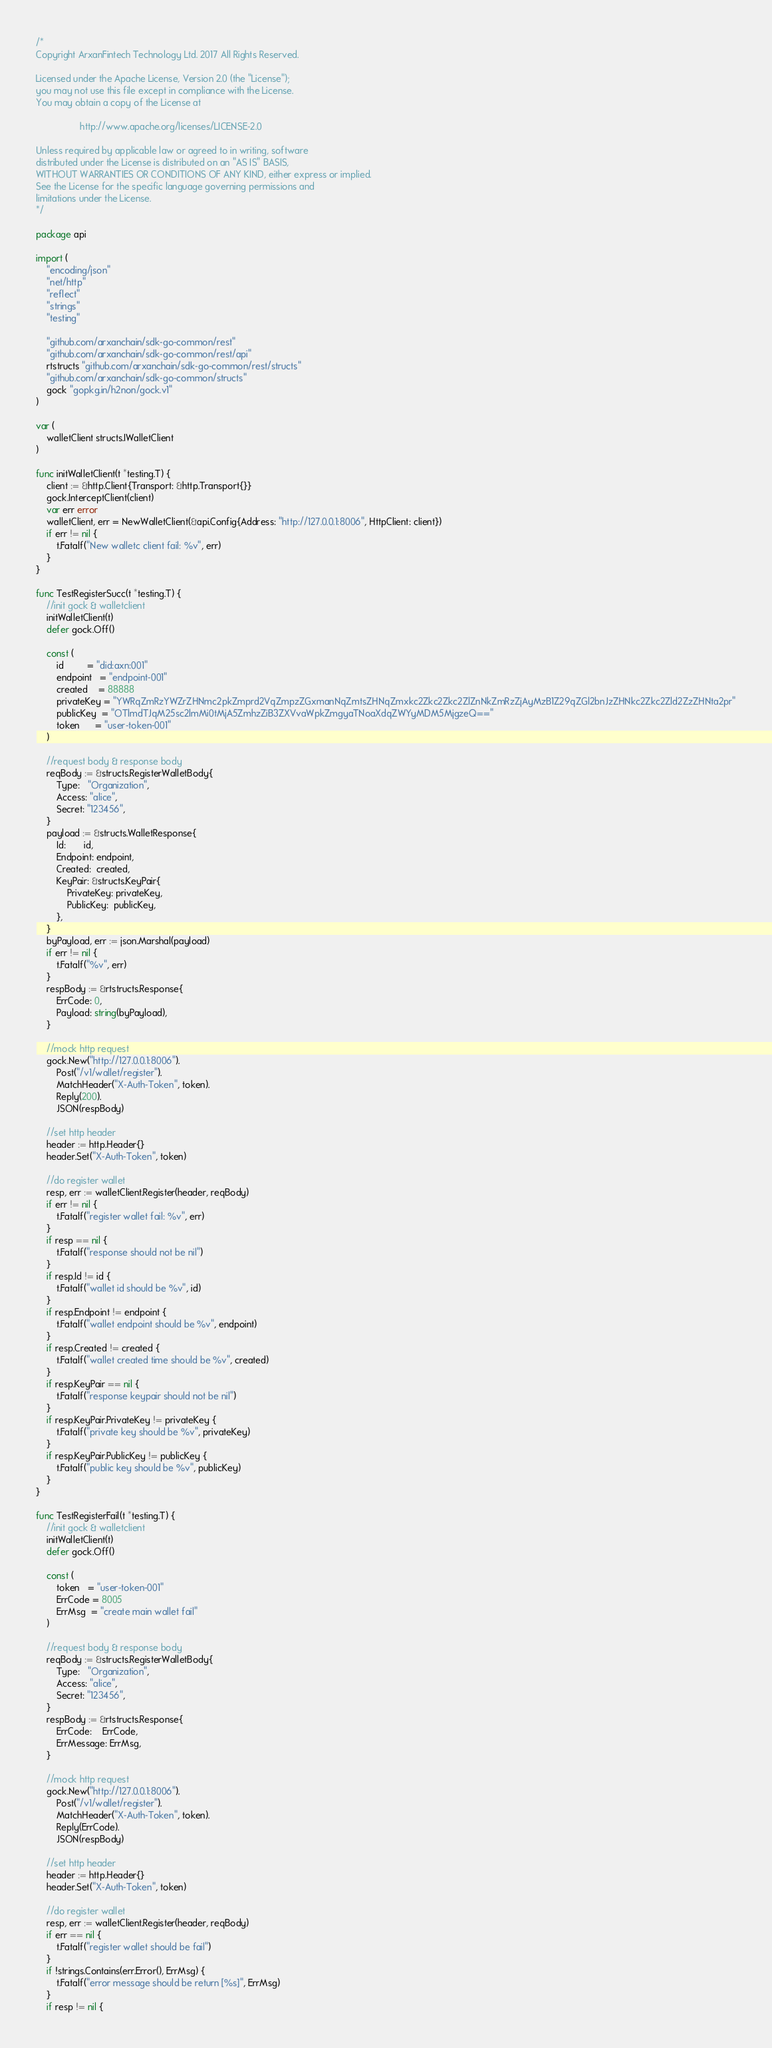Convert code to text. <code><loc_0><loc_0><loc_500><loc_500><_Go_>/*
Copyright ArxanFintech Technology Ltd. 2017 All Rights Reserved.

Licensed under the Apache License, Version 2.0 (the "License");
you may not use this file except in compliance with the License.
You may obtain a copy of the License at

                 http://www.apache.org/licenses/LICENSE-2.0

Unless required by applicable law or agreed to in writing, software
distributed under the License is distributed on an "AS IS" BASIS,
WITHOUT WARRANTIES OR CONDITIONS OF ANY KIND, either express or implied.
See the License for the specific language governing permissions and
limitations under the License.
*/

package api

import (
	"encoding/json"
	"net/http"
	"reflect"
	"strings"
	"testing"

	"github.com/arxanchain/sdk-go-common/rest"
	"github.com/arxanchain/sdk-go-common/rest/api"
	rtstructs "github.com/arxanchain/sdk-go-common/rest/structs"
	"github.com/arxanchain/sdk-go-common/structs"
	gock "gopkg.in/h2non/gock.v1"
)

var (
	walletClient structs.IWalletClient
)

func initWalletClient(t *testing.T) {
	client := &http.Client{Transport: &http.Transport{}}
	gock.InterceptClient(client)
	var err error
	walletClient, err = NewWalletClient(&api.Config{Address: "http://127.0.0.1:8006", HttpClient: client})
	if err != nil {
		t.Fatalf("New walletc client fail: %v", err)
	}
}

func TestRegisterSucc(t *testing.T) {
	//init gock & walletclient
	initWalletClient(t)
	defer gock.Off()

	const (
		id         = "did:axn:001"
		endpoint   = "endpoint-001"
		created    = 88888
		privateKey = "YWRqZmRzYWZrZHNmc2pkZmprd2VqZmpzZGxmanNqZmtsZHNqZmxkc2Zkc2Zkc2ZlZnNkZmRzZjAyMzB1Z29qZGl2bnJzZHNkc2Zkc2Zld2ZzZHNta2pr"
		publicKey  = "OTlmdTJqM25sc2lmMi0tMjA5ZmhzZiB3ZXVvaWpkZmgyaTNoaXdqZWYyMDM5MjgzeQ=="
		token      = "user-token-001"
	)

	//request body & response body
	reqBody := &structs.RegisterWalletBody{
		Type:   "Organization",
		Access: "alice",
		Secret: "123456",
	}
	payload := &structs.WalletResponse{
		Id:       id,
		Endpoint: endpoint,
		Created:  created,
		KeyPair: &structs.KeyPair{
			PrivateKey: privateKey,
			PublicKey:  publicKey,
		},
	}
	byPayload, err := json.Marshal(payload)
	if err != nil {
		t.Fatalf("%v", err)
	}
	respBody := &rtstructs.Response{
		ErrCode: 0,
		Payload: string(byPayload),
	}

	//mock http request
	gock.New("http://127.0.0.1:8006").
		Post("/v1/wallet/register").
		MatchHeader("X-Auth-Token", token).
		Reply(200).
		JSON(respBody)

	//set http header
	header := http.Header{}
	header.Set("X-Auth-Token", token)

	//do register wallet
	resp, err := walletClient.Register(header, reqBody)
	if err != nil {
		t.Fatalf("register wallet fail: %v", err)
	}
	if resp == nil {
		t.Fatalf("response should not be nil")
	}
	if resp.Id != id {
		t.Fatalf("wallet id should be %v", id)
	}
	if resp.Endpoint != endpoint {
		t.Fatalf("wallet endpoint should be %v", endpoint)
	}
	if resp.Created != created {
		t.Fatalf("wallet created time should be %v", created)
	}
	if resp.KeyPair == nil {
		t.Fatalf("response keypair should not be nil")
	}
	if resp.KeyPair.PrivateKey != privateKey {
		t.Fatalf("private key should be %v", privateKey)
	}
	if resp.KeyPair.PublicKey != publicKey {
		t.Fatalf("public key should be %v", publicKey)
	}
}

func TestRegisterFail(t *testing.T) {
	//init gock & walletclient
	initWalletClient(t)
	defer gock.Off()

	const (
		token   = "user-token-001"
		ErrCode = 8005
		ErrMsg  = "create main wallet fail"
	)

	//request body & response body
	reqBody := &structs.RegisterWalletBody{
		Type:   "Organization",
		Access: "alice",
		Secret: "123456",
	}
	respBody := &rtstructs.Response{
		ErrCode:    ErrCode,
		ErrMessage: ErrMsg,
	}

	//mock http request
	gock.New("http://127.0.0.1:8006").
		Post("/v1/wallet/register").
		MatchHeader("X-Auth-Token", token).
		Reply(ErrCode).
		JSON(respBody)

	//set http header
	header := http.Header{}
	header.Set("X-Auth-Token", token)

	//do register wallet
	resp, err := walletClient.Register(header, reqBody)
	if err == nil {
		t.Fatalf("register wallet should be fail")
	}
	if !strings.Contains(err.Error(), ErrMsg) {
		t.Fatalf("error message should be return [%s]", ErrMsg)
	}
	if resp != nil {</code> 